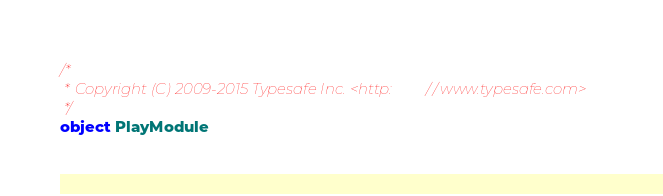<code> <loc_0><loc_0><loc_500><loc_500><_Scala_>/*
 * Copyright (C) 2009-2015 Typesafe Inc. <http://www.typesafe.com>
 */
object PlayModule</code> 